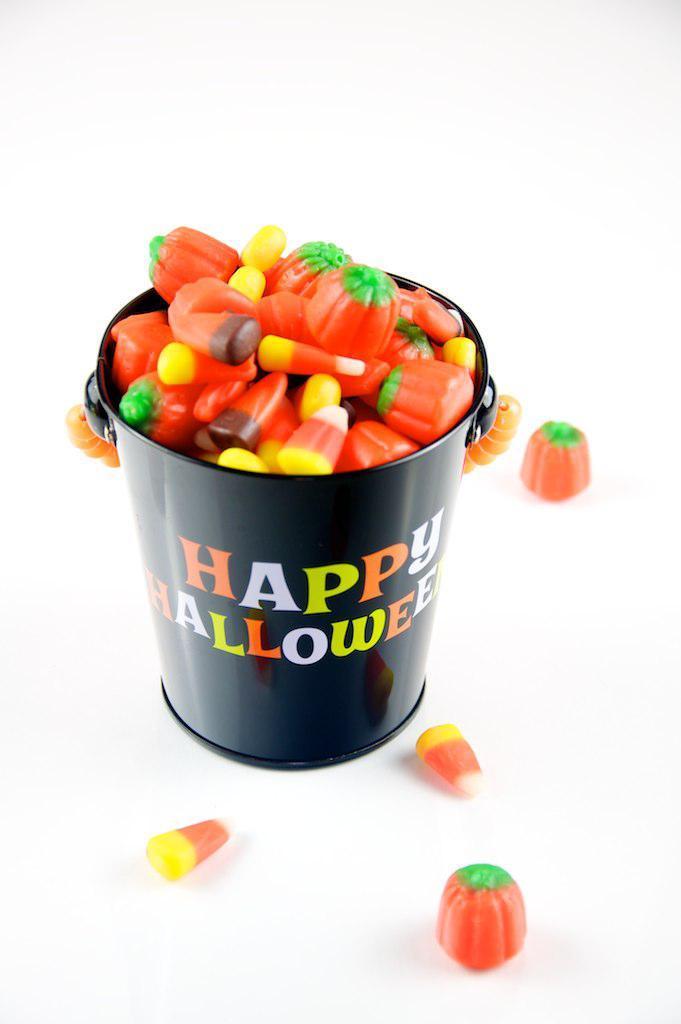Can you describe this image briefly? In the center of the image we can see toys in a bucket. 